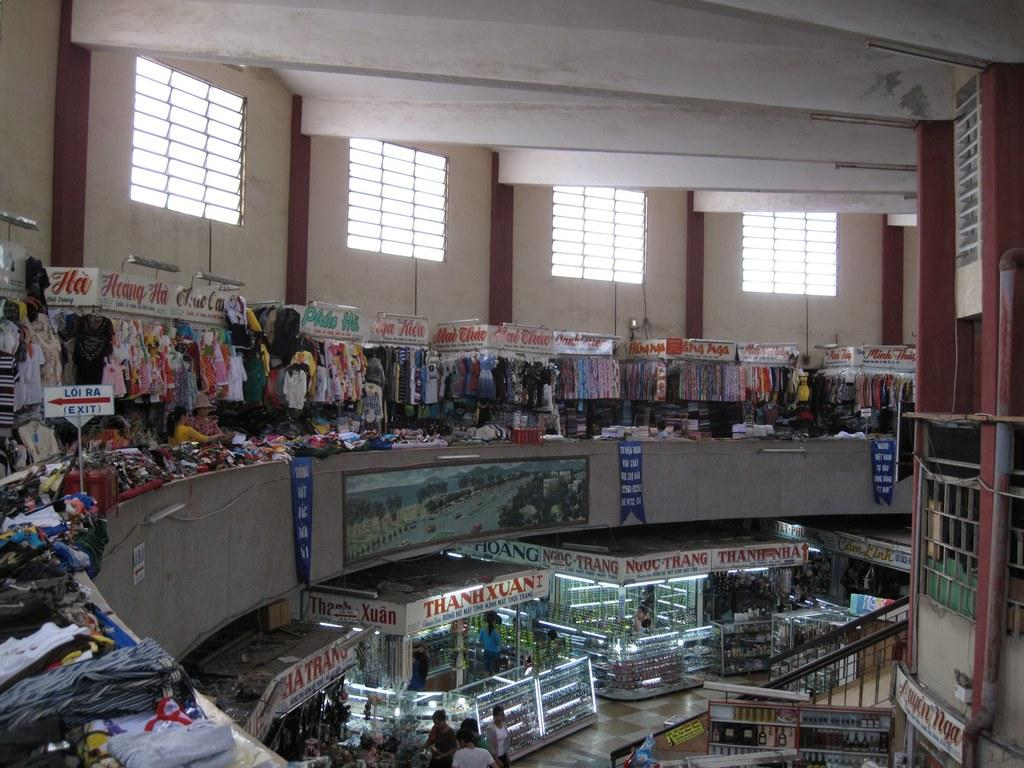<image>
Share a concise interpretation of the image provided. Store mall with a stand that says ThanhXuan. 